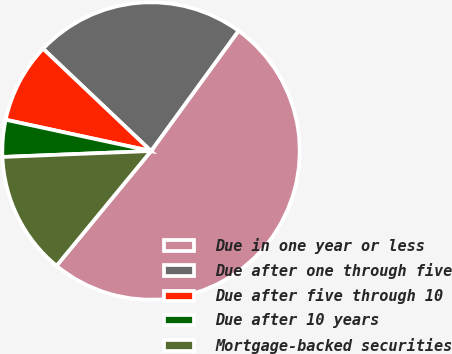Convert chart. <chart><loc_0><loc_0><loc_500><loc_500><pie_chart><fcel>Due in one year or less<fcel>Due after one through five<fcel>Due after five through 10<fcel>Due after 10 years<fcel>Mortgage-backed securities<nl><fcel>50.95%<fcel>22.94%<fcel>8.7%<fcel>4.01%<fcel>13.4%<nl></chart> 